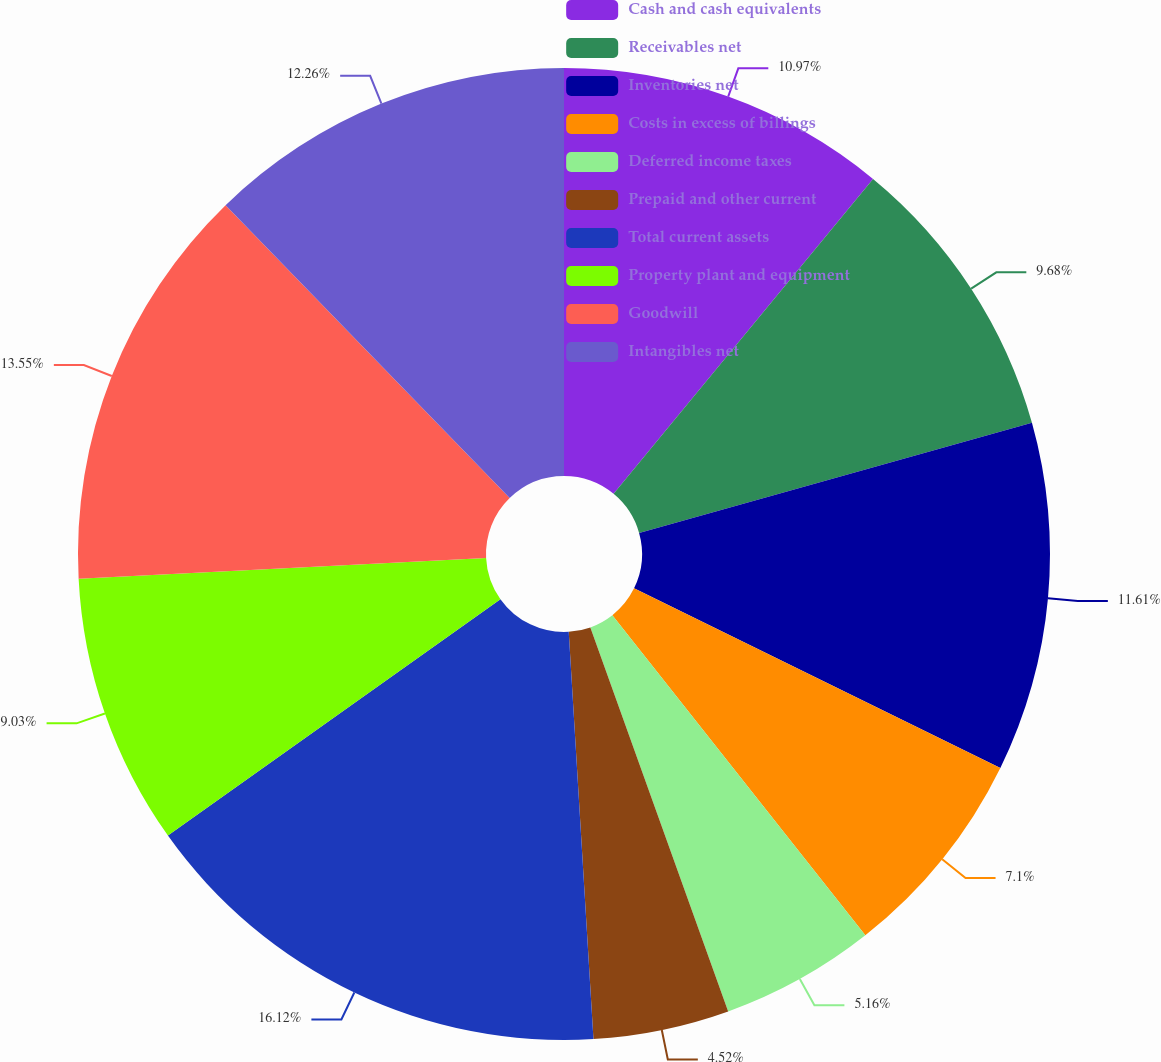Convert chart to OTSL. <chart><loc_0><loc_0><loc_500><loc_500><pie_chart><fcel>Cash and cash equivalents<fcel>Receivables net<fcel>Inventories net<fcel>Costs in excess of billings<fcel>Deferred income taxes<fcel>Prepaid and other current<fcel>Total current assets<fcel>Property plant and equipment<fcel>Goodwill<fcel>Intangibles net<nl><fcel>10.97%<fcel>9.68%<fcel>11.61%<fcel>7.1%<fcel>5.16%<fcel>4.52%<fcel>16.13%<fcel>9.03%<fcel>13.55%<fcel>12.26%<nl></chart> 